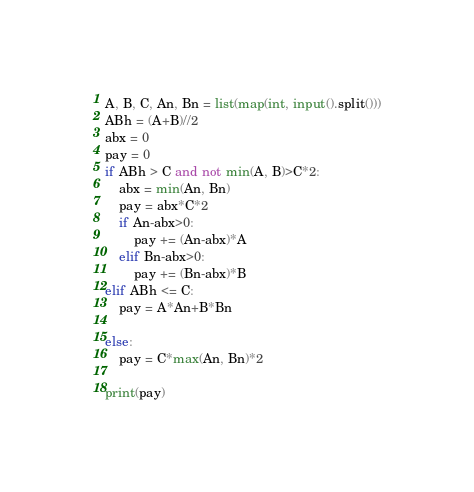Convert code to text. <code><loc_0><loc_0><loc_500><loc_500><_Python_>A, B, C, An, Bn = list(map(int, input().split()))
ABh = (A+B)//2
abx = 0
pay = 0
if ABh > C and not min(A, B)>C*2:
    abx = min(An, Bn)
    pay = abx*C*2
    if An-abx>0:
        pay += (An-abx)*A
    elif Bn-abx>0:
        pay += (Bn-abx)*B
elif ABh <= C:
    pay = A*An+B*Bn

else:
    pay = C*max(An, Bn)*2
    
print(pay)</code> 